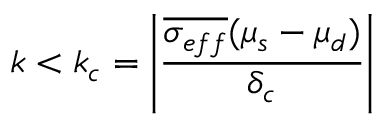<formula> <loc_0><loc_0><loc_500><loc_500>k < k _ { c } = \left | \frac { \overline { { \sigma _ { e f f } } } ( \mu _ { s } - \mu _ { d } ) } { \delta _ { c } } \right |</formula> 